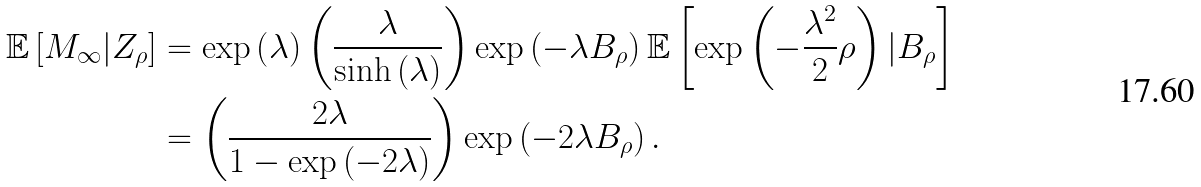Convert formula to latex. <formula><loc_0><loc_0><loc_500><loc_500>\mathbb { E } \left [ M _ { \infty } | Z _ { \rho } \right ] & = \exp \left ( \lambda \right ) \left ( \frac { \lambda } { \sinh \left ( \lambda \right ) } \right ) \exp \left ( - \lambda B _ { \rho } \right ) \mathbb { E } \left [ \exp \left ( - \frac { \lambda ^ { 2 } } { 2 } \rho \right ) | B _ { \rho } \right ] \\ & = \left ( \frac { 2 \lambda } { 1 - \exp \left ( - 2 \lambda \right ) } \right ) \exp \left ( - 2 \lambda B _ { \rho } \right ) .</formula> 